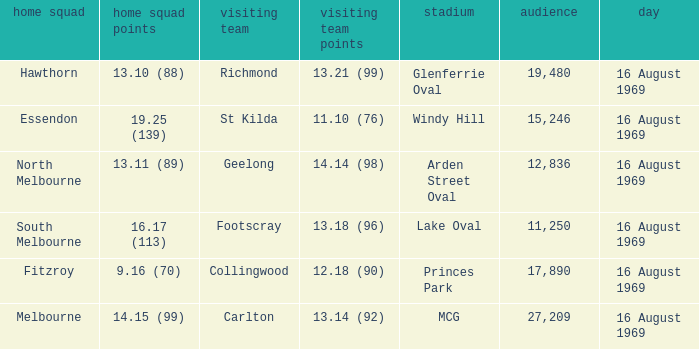What was the away team when the game was at Princes Park? Collingwood. 